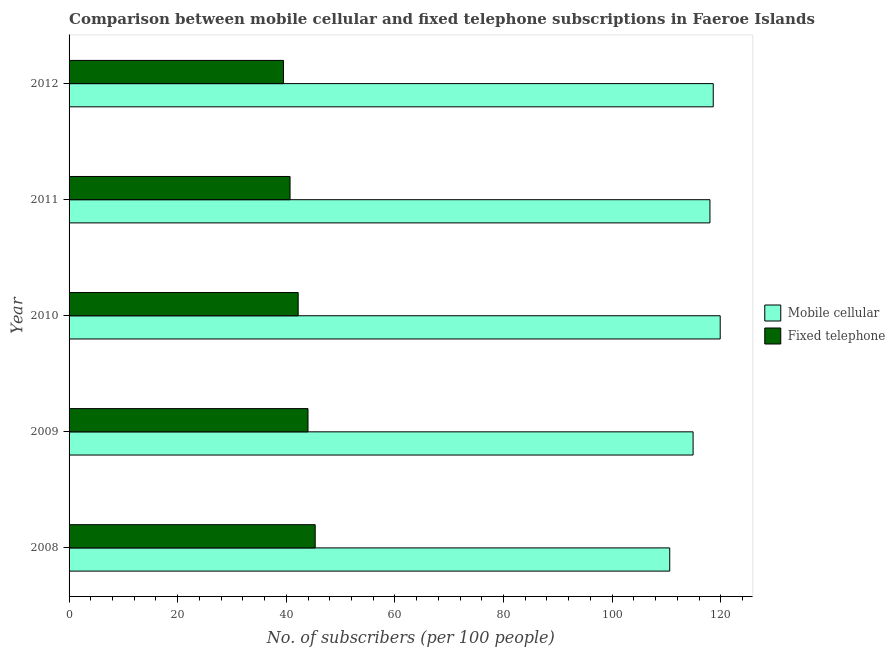How many groups of bars are there?
Provide a succinct answer. 5. How many bars are there on the 2nd tick from the top?
Offer a very short reply. 2. What is the number of fixed telephone subscribers in 2012?
Your answer should be very brief. 39.48. Across all years, what is the maximum number of mobile cellular subscribers?
Keep it short and to the point. 119.9. Across all years, what is the minimum number of fixed telephone subscribers?
Make the answer very short. 39.48. In which year was the number of mobile cellular subscribers maximum?
Ensure brevity in your answer.  2010. What is the total number of fixed telephone subscribers in the graph?
Offer a very short reply. 211.67. What is the difference between the number of fixed telephone subscribers in 2008 and that in 2012?
Provide a short and direct response. 5.85. What is the difference between the number of fixed telephone subscribers in 2008 and the number of mobile cellular subscribers in 2010?
Keep it short and to the point. -74.57. What is the average number of fixed telephone subscribers per year?
Make the answer very short. 42.33. In the year 2009, what is the difference between the number of mobile cellular subscribers and number of fixed telephone subscribers?
Your answer should be compact. 70.91. In how many years, is the number of mobile cellular subscribers greater than 108 ?
Ensure brevity in your answer.  5. What is the ratio of the number of mobile cellular subscribers in 2009 to that in 2011?
Your response must be concise. 0.97. Is the number of fixed telephone subscribers in 2009 less than that in 2011?
Ensure brevity in your answer.  No. Is the difference between the number of mobile cellular subscribers in 2009 and 2010 greater than the difference between the number of fixed telephone subscribers in 2009 and 2010?
Provide a succinct answer. No. What is the difference between the highest and the second highest number of fixed telephone subscribers?
Keep it short and to the point. 1.33. What is the difference between the highest and the lowest number of mobile cellular subscribers?
Your answer should be very brief. 9.29. Is the sum of the number of mobile cellular subscribers in 2008 and 2011 greater than the maximum number of fixed telephone subscribers across all years?
Your response must be concise. Yes. What does the 1st bar from the top in 2009 represents?
Your answer should be compact. Fixed telephone. What does the 1st bar from the bottom in 2010 represents?
Your answer should be compact. Mobile cellular. How many bars are there?
Ensure brevity in your answer.  10. Are all the bars in the graph horizontal?
Offer a very short reply. Yes. How many years are there in the graph?
Your answer should be compact. 5. Are the values on the major ticks of X-axis written in scientific E-notation?
Your answer should be very brief. No. Does the graph contain any zero values?
Your answer should be very brief. No. Does the graph contain grids?
Offer a terse response. No. Where does the legend appear in the graph?
Your answer should be compact. Center right. How many legend labels are there?
Your response must be concise. 2. What is the title of the graph?
Offer a very short reply. Comparison between mobile cellular and fixed telephone subscriptions in Faeroe Islands. Does "Males" appear as one of the legend labels in the graph?
Your answer should be very brief. No. What is the label or title of the X-axis?
Keep it short and to the point. No. of subscribers (per 100 people). What is the No. of subscribers (per 100 people) in Mobile cellular in 2008?
Offer a terse response. 110.6. What is the No. of subscribers (per 100 people) in Fixed telephone in 2008?
Ensure brevity in your answer.  45.32. What is the No. of subscribers (per 100 people) in Mobile cellular in 2009?
Provide a succinct answer. 114.91. What is the No. of subscribers (per 100 people) of Fixed telephone in 2009?
Your answer should be compact. 44. What is the No. of subscribers (per 100 people) of Mobile cellular in 2010?
Ensure brevity in your answer.  119.9. What is the No. of subscribers (per 100 people) in Fixed telephone in 2010?
Keep it short and to the point. 42.19. What is the No. of subscribers (per 100 people) in Mobile cellular in 2011?
Your response must be concise. 118.01. What is the No. of subscribers (per 100 people) of Fixed telephone in 2011?
Give a very brief answer. 40.69. What is the No. of subscribers (per 100 people) of Mobile cellular in 2012?
Ensure brevity in your answer.  118.62. What is the No. of subscribers (per 100 people) of Fixed telephone in 2012?
Your answer should be compact. 39.48. Across all years, what is the maximum No. of subscribers (per 100 people) in Mobile cellular?
Offer a very short reply. 119.9. Across all years, what is the maximum No. of subscribers (per 100 people) of Fixed telephone?
Make the answer very short. 45.32. Across all years, what is the minimum No. of subscribers (per 100 people) of Mobile cellular?
Offer a very short reply. 110.6. Across all years, what is the minimum No. of subscribers (per 100 people) of Fixed telephone?
Ensure brevity in your answer.  39.48. What is the total No. of subscribers (per 100 people) in Mobile cellular in the graph?
Your answer should be very brief. 582.03. What is the total No. of subscribers (per 100 people) in Fixed telephone in the graph?
Provide a succinct answer. 211.67. What is the difference between the No. of subscribers (per 100 people) of Mobile cellular in 2008 and that in 2009?
Offer a terse response. -4.3. What is the difference between the No. of subscribers (per 100 people) of Fixed telephone in 2008 and that in 2009?
Offer a terse response. 1.33. What is the difference between the No. of subscribers (per 100 people) in Mobile cellular in 2008 and that in 2010?
Your answer should be very brief. -9.29. What is the difference between the No. of subscribers (per 100 people) in Fixed telephone in 2008 and that in 2010?
Provide a succinct answer. 3.14. What is the difference between the No. of subscribers (per 100 people) in Mobile cellular in 2008 and that in 2011?
Provide a succinct answer. -7.41. What is the difference between the No. of subscribers (per 100 people) of Fixed telephone in 2008 and that in 2011?
Offer a very short reply. 4.63. What is the difference between the No. of subscribers (per 100 people) of Mobile cellular in 2008 and that in 2012?
Your answer should be compact. -8.01. What is the difference between the No. of subscribers (per 100 people) of Fixed telephone in 2008 and that in 2012?
Provide a succinct answer. 5.85. What is the difference between the No. of subscribers (per 100 people) of Mobile cellular in 2009 and that in 2010?
Make the answer very short. -4.99. What is the difference between the No. of subscribers (per 100 people) of Fixed telephone in 2009 and that in 2010?
Give a very brief answer. 1.81. What is the difference between the No. of subscribers (per 100 people) of Mobile cellular in 2009 and that in 2011?
Offer a very short reply. -3.1. What is the difference between the No. of subscribers (per 100 people) in Fixed telephone in 2009 and that in 2011?
Provide a short and direct response. 3.3. What is the difference between the No. of subscribers (per 100 people) of Mobile cellular in 2009 and that in 2012?
Offer a very short reply. -3.71. What is the difference between the No. of subscribers (per 100 people) of Fixed telephone in 2009 and that in 2012?
Keep it short and to the point. 4.52. What is the difference between the No. of subscribers (per 100 people) of Mobile cellular in 2010 and that in 2011?
Offer a terse response. 1.89. What is the difference between the No. of subscribers (per 100 people) in Fixed telephone in 2010 and that in 2011?
Offer a very short reply. 1.49. What is the difference between the No. of subscribers (per 100 people) in Mobile cellular in 2010 and that in 2012?
Your answer should be very brief. 1.28. What is the difference between the No. of subscribers (per 100 people) of Fixed telephone in 2010 and that in 2012?
Ensure brevity in your answer.  2.71. What is the difference between the No. of subscribers (per 100 people) in Mobile cellular in 2011 and that in 2012?
Give a very brief answer. -0.61. What is the difference between the No. of subscribers (per 100 people) in Fixed telephone in 2011 and that in 2012?
Your answer should be very brief. 1.21. What is the difference between the No. of subscribers (per 100 people) in Mobile cellular in 2008 and the No. of subscribers (per 100 people) in Fixed telephone in 2009?
Keep it short and to the point. 66.61. What is the difference between the No. of subscribers (per 100 people) in Mobile cellular in 2008 and the No. of subscribers (per 100 people) in Fixed telephone in 2010?
Your response must be concise. 68.42. What is the difference between the No. of subscribers (per 100 people) of Mobile cellular in 2008 and the No. of subscribers (per 100 people) of Fixed telephone in 2011?
Make the answer very short. 69.91. What is the difference between the No. of subscribers (per 100 people) of Mobile cellular in 2008 and the No. of subscribers (per 100 people) of Fixed telephone in 2012?
Your answer should be compact. 71.13. What is the difference between the No. of subscribers (per 100 people) in Mobile cellular in 2009 and the No. of subscribers (per 100 people) in Fixed telephone in 2010?
Your answer should be very brief. 72.72. What is the difference between the No. of subscribers (per 100 people) in Mobile cellular in 2009 and the No. of subscribers (per 100 people) in Fixed telephone in 2011?
Offer a very short reply. 74.21. What is the difference between the No. of subscribers (per 100 people) of Mobile cellular in 2009 and the No. of subscribers (per 100 people) of Fixed telephone in 2012?
Provide a succinct answer. 75.43. What is the difference between the No. of subscribers (per 100 people) in Mobile cellular in 2010 and the No. of subscribers (per 100 people) in Fixed telephone in 2011?
Offer a very short reply. 79.21. What is the difference between the No. of subscribers (per 100 people) of Mobile cellular in 2010 and the No. of subscribers (per 100 people) of Fixed telephone in 2012?
Provide a short and direct response. 80.42. What is the difference between the No. of subscribers (per 100 people) of Mobile cellular in 2011 and the No. of subscribers (per 100 people) of Fixed telephone in 2012?
Make the answer very short. 78.53. What is the average No. of subscribers (per 100 people) in Mobile cellular per year?
Provide a short and direct response. 116.41. What is the average No. of subscribers (per 100 people) in Fixed telephone per year?
Your answer should be compact. 42.33. In the year 2008, what is the difference between the No. of subscribers (per 100 people) in Mobile cellular and No. of subscribers (per 100 people) in Fixed telephone?
Your answer should be very brief. 65.28. In the year 2009, what is the difference between the No. of subscribers (per 100 people) in Mobile cellular and No. of subscribers (per 100 people) in Fixed telephone?
Keep it short and to the point. 70.91. In the year 2010, what is the difference between the No. of subscribers (per 100 people) in Mobile cellular and No. of subscribers (per 100 people) in Fixed telephone?
Ensure brevity in your answer.  77.71. In the year 2011, what is the difference between the No. of subscribers (per 100 people) in Mobile cellular and No. of subscribers (per 100 people) in Fixed telephone?
Provide a short and direct response. 77.32. In the year 2012, what is the difference between the No. of subscribers (per 100 people) in Mobile cellular and No. of subscribers (per 100 people) in Fixed telephone?
Make the answer very short. 79.14. What is the ratio of the No. of subscribers (per 100 people) in Mobile cellular in 2008 to that in 2009?
Give a very brief answer. 0.96. What is the ratio of the No. of subscribers (per 100 people) of Fixed telephone in 2008 to that in 2009?
Your response must be concise. 1.03. What is the ratio of the No. of subscribers (per 100 people) in Mobile cellular in 2008 to that in 2010?
Offer a terse response. 0.92. What is the ratio of the No. of subscribers (per 100 people) of Fixed telephone in 2008 to that in 2010?
Provide a succinct answer. 1.07. What is the ratio of the No. of subscribers (per 100 people) of Mobile cellular in 2008 to that in 2011?
Keep it short and to the point. 0.94. What is the ratio of the No. of subscribers (per 100 people) of Fixed telephone in 2008 to that in 2011?
Your answer should be very brief. 1.11. What is the ratio of the No. of subscribers (per 100 people) of Mobile cellular in 2008 to that in 2012?
Provide a short and direct response. 0.93. What is the ratio of the No. of subscribers (per 100 people) of Fixed telephone in 2008 to that in 2012?
Keep it short and to the point. 1.15. What is the ratio of the No. of subscribers (per 100 people) in Mobile cellular in 2009 to that in 2010?
Your response must be concise. 0.96. What is the ratio of the No. of subscribers (per 100 people) of Fixed telephone in 2009 to that in 2010?
Offer a very short reply. 1.04. What is the ratio of the No. of subscribers (per 100 people) of Mobile cellular in 2009 to that in 2011?
Make the answer very short. 0.97. What is the ratio of the No. of subscribers (per 100 people) in Fixed telephone in 2009 to that in 2011?
Provide a short and direct response. 1.08. What is the ratio of the No. of subscribers (per 100 people) of Mobile cellular in 2009 to that in 2012?
Make the answer very short. 0.97. What is the ratio of the No. of subscribers (per 100 people) in Fixed telephone in 2009 to that in 2012?
Make the answer very short. 1.11. What is the ratio of the No. of subscribers (per 100 people) in Fixed telephone in 2010 to that in 2011?
Provide a short and direct response. 1.04. What is the ratio of the No. of subscribers (per 100 people) of Mobile cellular in 2010 to that in 2012?
Your response must be concise. 1.01. What is the ratio of the No. of subscribers (per 100 people) of Fixed telephone in 2010 to that in 2012?
Give a very brief answer. 1.07. What is the ratio of the No. of subscribers (per 100 people) of Mobile cellular in 2011 to that in 2012?
Give a very brief answer. 0.99. What is the ratio of the No. of subscribers (per 100 people) of Fixed telephone in 2011 to that in 2012?
Give a very brief answer. 1.03. What is the difference between the highest and the second highest No. of subscribers (per 100 people) of Mobile cellular?
Your answer should be very brief. 1.28. What is the difference between the highest and the second highest No. of subscribers (per 100 people) in Fixed telephone?
Make the answer very short. 1.33. What is the difference between the highest and the lowest No. of subscribers (per 100 people) in Mobile cellular?
Your response must be concise. 9.29. What is the difference between the highest and the lowest No. of subscribers (per 100 people) of Fixed telephone?
Make the answer very short. 5.85. 